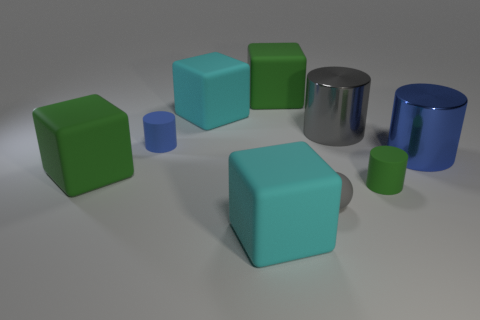How does lighting affect the objects in the scene? Lighting plays a crucial role in the scene by highlighting the geometry and material properties of the objects. It appears to be a standard three-point lighting setup with a key light, fill light, and backlight that create softly diffused shadows and defined highlights. These lighting conditions not only reveal the individual character of each object's surface but also establish depth, making the scene more visually engaging and easier to interpret. 